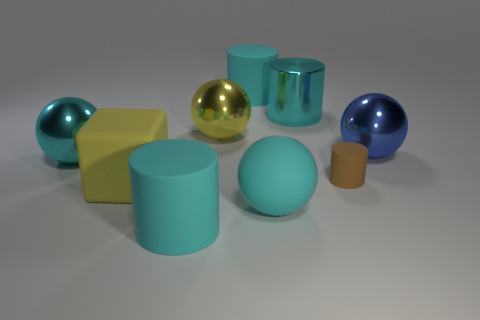Subtract all green blocks. How many brown cylinders are left? 1 Add 1 cyan balls. How many objects exist? 10 Subtract all yellow balls. How many balls are left? 3 Subtract all shiny cylinders. How many cylinders are left? 3 How many cyan cylinders must be subtracted to get 1 cyan cylinders? 2 Subtract all balls. How many objects are left? 5 Subtract 2 balls. How many balls are left? 2 Subtract all purple blocks. Subtract all purple balls. How many blocks are left? 1 Subtract all metal cylinders. Subtract all metal cylinders. How many objects are left? 7 Add 7 big cyan balls. How many big cyan balls are left? 9 